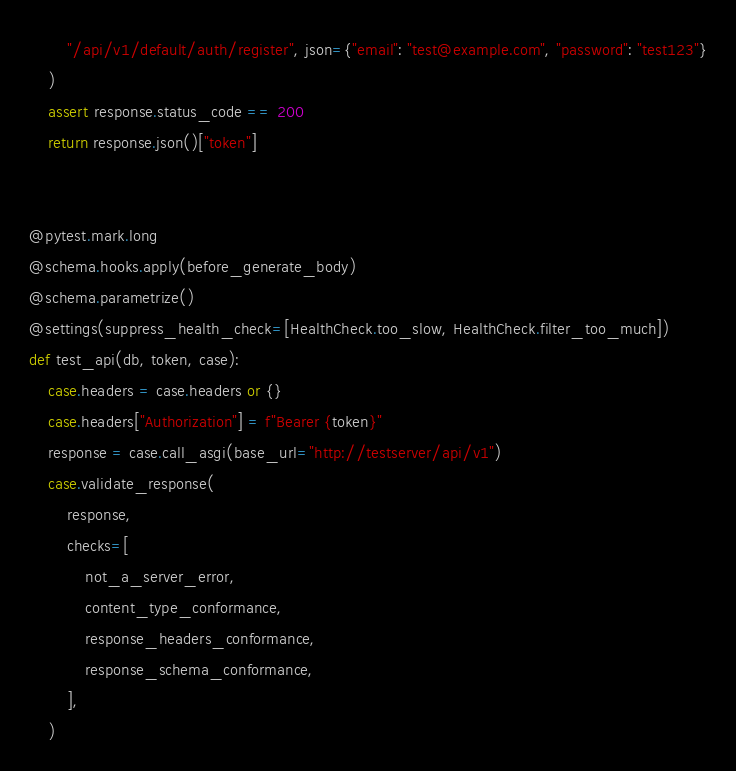Convert code to text. <code><loc_0><loc_0><loc_500><loc_500><_Python_>        "/api/v1/default/auth/register", json={"email": "test@example.com", "password": "test123"}
    )
    assert response.status_code == 200
    return response.json()["token"]


@pytest.mark.long
@schema.hooks.apply(before_generate_body)
@schema.parametrize()
@settings(suppress_health_check=[HealthCheck.too_slow, HealthCheck.filter_too_much])
def test_api(db, token, case):
    case.headers = case.headers or {}
    case.headers["Authorization"] = f"Bearer {token}"
    response = case.call_asgi(base_url="http://testserver/api/v1")
    case.validate_response(
        response,
        checks=[
            not_a_server_error,
            content_type_conformance,
            response_headers_conformance,
            response_schema_conformance,
        ],
    )
</code> 